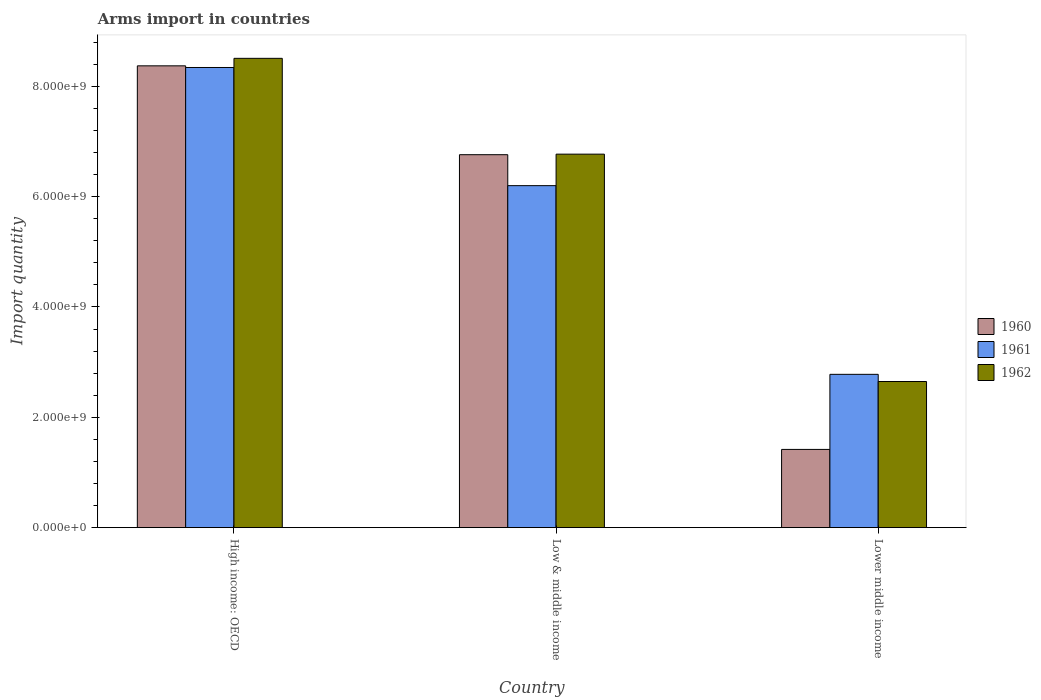How many bars are there on the 1st tick from the left?
Offer a terse response. 3. How many bars are there on the 2nd tick from the right?
Your response must be concise. 3. What is the total arms import in 1961 in Lower middle income?
Your answer should be very brief. 2.78e+09. Across all countries, what is the maximum total arms import in 1962?
Offer a terse response. 8.51e+09. Across all countries, what is the minimum total arms import in 1960?
Provide a short and direct response. 1.42e+09. In which country was the total arms import in 1962 maximum?
Keep it short and to the point. High income: OECD. In which country was the total arms import in 1960 minimum?
Give a very brief answer. Lower middle income. What is the total total arms import in 1960 in the graph?
Offer a very short reply. 1.66e+1. What is the difference between the total arms import in 1962 in High income: OECD and that in Low & middle income?
Your response must be concise. 1.74e+09. What is the difference between the total arms import in 1960 in Low & middle income and the total arms import in 1961 in Lower middle income?
Give a very brief answer. 3.98e+09. What is the average total arms import in 1960 per country?
Give a very brief answer. 5.52e+09. What is the difference between the total arms import of/in 1962 and total arms import of/in 1960 in Low & middle income?
Make the answer very short. 1.00e+07. What is the ratio of the total arms import in 1961 in Low & middle income to that in Lower middle income?
Offer a very short reply. 2.23. Is the total arms import in 1960 in High income: OECD less than that in Lower middle income?
Your answer should be compact. No. Is the difference between the total arms import in 1962 in Low & middle income and Lower middle income greater than the difference between the total arms import in 1960 in Low & middle income and Lower middle income?
Provide a succinct answer. No. What is the difference between the highest and the second highest total arms import in 1962?
Make the answer very short. 5.86e+09. What is the difference between the highest and the lowest total arms import in 1961?
Offer a terse response. 5.56e+09. In how many countries, is the total arms import in 1962 greater than the average total arms import in 1962 taken over all countries?
Your response must be concise. 2. Is the sum of the total arms import in 1960 in High income: OECD and Lower middle income greater than the maximum total arms import in 1961 across all countries?
Your answer should be very brief. Yes. Is it the case that in every country, the sum of the total arms import in 1962 and total arms import in 1960 is greater than the total arms import in 1961?
Keep it short and to the point. Yes. Are all the bars in the graph horizontal?
Ensure brevity in your answer.  No. What is the difference between two consecutive major ticks on the Y-axis?
Offer a terse response. 2.00e+09. Does the graph contain any zero values?
Offer a very short reply. No. Does the graph contain grids?
Ensure brevity in your answer.  No. How are the legend labels stacked?
Offer a terse response. Vertical. What is the title of the graph?
Keep it short and to the point. Arms import in countries. What is the label or title of the X-axis?
Offer a very short reply. Country. What is the label or title of the Y-axis?
Offer a terse response. Import quantity. What is the Import quantity of 1960 in High income: OECD?
Offer a terse response. 8.37e+09. What is the Import quantity in 1961 in High income: OECD?
Ensure brevity in your answer.  8.34e+09. What is the Import quantity of 1962 in High income: OECD?
Keep it short and to the point. 8.51e+09. What is the Import quantity in 1960 in Low & middle income?
Offer a terse response. 6.76e+09. What is the Import quantity in 1961 in Low & middle income?
Provide a short and direct response. 6.20e+09. What is the Import quantity of 1962 in Low & middle income?
Provide a short and direct response. 6.77e+09. What is the Import quantity of 1960 in Lower middle income?
Your response must be concise. 1.42e+09. What is the Import quantity of 1961 in Lower middle income?
Your answer should be compact. 2.78e+09. What is the Import quantity in 1962 in Lower middle income?
Provide a succinct answer. 2.65e+09. Across all countries, what is the maximum Import quantity in 1960?
Your response must be concise. 8.37e+09. Across all countries, what is the maximum Import quantity in 1961?
Make the answer very short. 8.34e+09. Across all countries, what is the maximum Import quantity in 1962?
Your response must be concise. 8.51e+09. Across all countries, what is the minimum Import quantity of 1960?
Make the answer very short. 1.42e+09. Across all countries, what is the minimum Import quantity in 1961?
Your response must be concise. 2.78e+09. Across all countries, what is the minimum Import quantity in 1962?
Ensure brevity in your answer.  2.65e+09. What is the total Import quantity of 1960 in the graph?
Offer a very short reply. 1.66e+1. What is the total Import quantity in 1961 in the graph?
Your answer should be very brief. 1.73e+1. What is the total Import quantity of 1962 in the graph?
Your answer should be very brief. 1.79e+1. What is the difference between the Import quantity in 1960 in High income: OECD and that in Low & middle income?
Make the answer very short. 1.61e+09. What is the difference between the Import quantity of 1961 in High income: OECD and that in Low & middle income?
Provide a succinct answer. 2.14e+09. What is the difference between the Import quantity in 1962 in High income: OECD and that in Low & middle income?
Offer a very short reply. 1.74e+09. What is the difference between the Import quantity in 1960 in High income: OECD and that in Lower middle income?
Give a very brief answer. 6.95e+09. What is the difference between the Import quantity in 1961 in High income: OECD and that in Lower middle income?
Your answer should be very brief. 5.56e+09. What is the difference between the Import quantity in 1962 in High income: OECD and that in Lower middle income?
Keep it short and to the point. 5.86e+09. What is the difference between the Import quantity of 1960 in Low & middle income and that in Lower middle income?
Ensure brevity in your answer.  5.34e+09. What is the difference between the Import quantity of 1961 in Low & middle income and that in Lower middle income?
Keep it short and to the point. 3.42e+09. What is the difference between the Import quantity of 1962 in Low & middle income and that in Lower middle income?
Provide a short and direct response. 4.12e+09. What is the difference between the Import quantity of 1960 in High income: OECD and the Import quantity of 1961 in Low & middle income?
Provide a short and direct response. 2.17e+09. What is the difference between the Import quantity of 1960 in High income: OECD and the Import quantity of 1962 in Low & middle income?
Give a very brief answer. 1.60e+09. What is the difference between the Import quantity of 1961 in High income: OECD and the Import quantity of 1962 in Low & middle income?
Your answer should be compact. 1.57e+09. What is the difference between the Import quantity of 1960 in High income: OECD and the Import quantity of 1961 in Lower middle income?
Provide a short and direct response. 5.59e+09. What is the difference between the Import quantity in 1960 in High income: OECD and the Import quantity in 1962 in Lower middle income?
Give a very brief answer. 5.72e+09. What is the difference between the Import quantity of 1961 in High income: OECD and the Import quantity of 1962 in Lower middle income?
Offer a terse response. 5.69e+09. What is the difference between the Import quantity in 1960 in Low & middle income and the Import quantity in 1961 in Lower middle income?
Your answer should be compact. 3.98e+09. What is the difference between the Import quantity of 1960 in Low & middle income and the Import quantity of 1962 in Lower middle income?
Make the answer very short. 4.11e+09. What is the difference between the Import quantity in 1961 in Low & middle income and the Import quantity in 1962 in Lower middle income?
Keep it short and to the point. 3.55e+09. What is the average Import quantity in 1960 per country?
Offer a very short reply. 5.52e+09. What is the average Import quantity of 1961 per country?
Your answer should be very brief. 5.77e+09. What is the average Import quantity of 1962 per country?
Your answer should be compact. 5.98e+09. What is the difference between the Import quantity of 1960 and Import quantity of 1961 in High income: OECD?
Ensure brevity in your answer.  3.00e+07. What is the difference between the Import quantity of 1960 and Import quantity of 1962 in High income: OECD?
Give a very brief answer. -1.36e+08. What is the difference between the Import quantity of 1961 and Import quantity of 1962 in High income: OECD?
Offer a very short reply. -1.66e+08. What is the difference between the Import quantity of 1960 and Import quantity of 1961 in Low & middle income?
Make the answer very short. 5.61e+08. What is the difference between the Import quantity of 1960 and Import quantity of 1962 in Low & middle income?
Provide a short and direct response. -1.00e+07. What is the difference between the Import quantity of 1961 and Import quantity of 1962 in Low & middle income?
Your answer should be compact. -5.71e+08. What is the difference between the Import quantity of 1960 and Import quantity of 1961 in Lower middle income?
Give a very brief answer. -1.36e+09. What is the difference between the Import quantity in 1960 and Import quantity in 1962 in Lower middle income?
Your answer should be very brief. -1.23e+09. What is the difference between the Import quantity in 1961 and Import quantity in 1962 in Lower middle income?
Offer a terse response. 1.30e+08. What is the ratio of the Import quantity of 1960 in High income: OECD to that in Low & middle income?
Give a very brief answer. 1.24. What is the ratio of the Import quantity of 1961 in High income: OECD to that in Low & middle income?
Your answer should be very brief. 1.35. What is the ratio of the Import quantity in 1962 in High income: OECD to that in Low & middle income?
Offer a terse response. 1.26. What is the ratio of the Import quantity of 1960 in High income: OECD to that in Lower middle income?
Your answer should be compact. 5.9. What is the ratio of the Import quantity in 1961 in High income: OECD to that in Lower middle income?
Provide a succinct answer. 3. What is the ratio of the Import quantity in 1962 in High income: OECD to that in Lower middle income?
Offer a very short reply. 3.21. What is the ratio of the Import quantity of 1960 in Low & middle income to that in Lower middle income?
Your answer should be compact. 4.77. What is the ratio of the Import quantity in 1961 in Low & middle income to that in Lower middle income?
Your response must be concise. 2.23. What is the ratio of the Import quantity of 1962 in Low & middle income to that in Lower middle income?
Provide a short and direct response. 2.56. What is the difference between the highest and the second highest Import quantity in 1960?
Make the answer very short. 1.61e+09. What is the difference between the highest and the second highest Import quantity in 1961?
Provide a succinct answer. 2.14e+09. What is the difference between the highest and the second highest Import quantity in 1962?
Provide a succinct answer. 1.74e+09. What is the difference between the highest and the lowest Import quantity in 1960?
Ensure brevity in your answer.  6.95e+09. What is the difference between the highest and the lowest Import quantity of 1961?
Provide a succinct answer. 5.56e+09. What is the difference between the highest and the lowest Import quantity of 1962?
Give a very brief answer. 5.86e+09. 